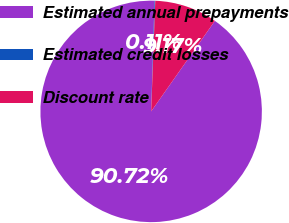Convert chart. <chart><loc_0><loc_0><loc_500><loc_500><pie_chart><fcel>Estimated annual prepayments<fcel>Estimated credit losses<fcel>Discount rate<nl><fcel>90.73%<fcel>0.11%<fcel>9.17%<nl></chart> 